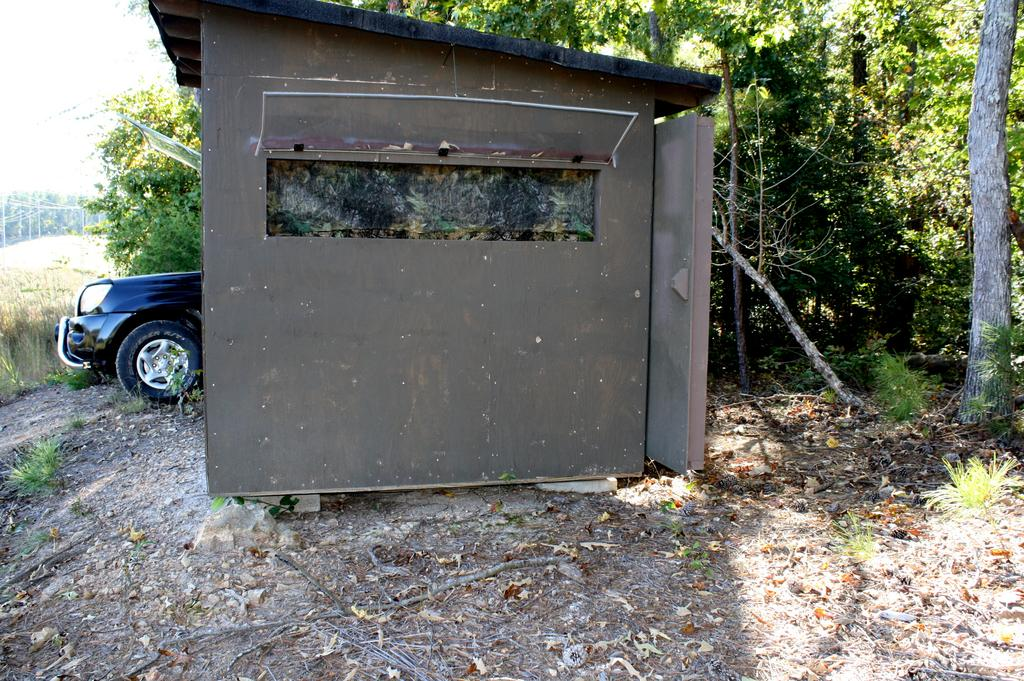What type of house is in the image? There is a wooden house in the image. Where is the house located? The house is on a surface in the image. What vehicle is in the image? There is a blue car in the image. How is the car positioned in relation to the house? The car is beside the house in the image. What can be seen on the ground in the image? There is a path in the image, and grass plants are visible on the path. What type of vegetation is present in the image? Trees are present in the image. Can you see any crows interacting with the nails in the veins of the house in the image? There are no crows, nails, or veins present in the image. 